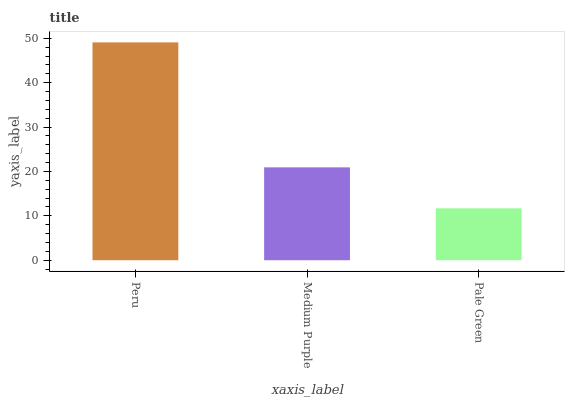Is Pale Green the minimum?
Answer yes or no. Yes. Is Peru the maximum?
Answer yes or no. Yes. Is Medium Purple the minimum?
Answer yes or no. No. Is Medium Purple the maximum?
Answer yes or no. No. Is Peru greater than Medium Purple?
Answer yes or no. Yes. Is Medium Purple less than Peru?
Answer yes or no. Yes. Is Medium Purple greater than Peru?
Answer yes or no. No. Is Peru less than Medium Purple?
Answer yes or no. No. Is Medium Purple the high median?
Answer yes or no. Yes. Is Medium Purple the low median?
Answer yes or no. Yes. Is Pale Green the high median?
Answer yes or no. No. Is Pale Green the low median?
Answer yes or no. No. 